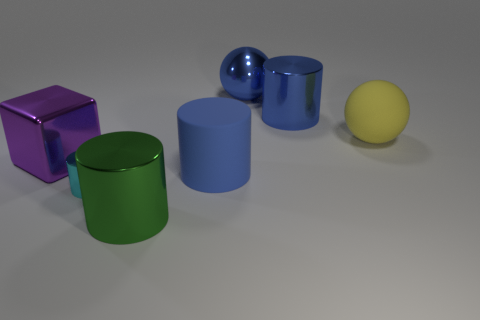Add 2 big purple cubes. How many objects exist? 9 Subtract all balls. How many objects are left? 5 Subtract 1 cyan cylinders. How many objects are left? 6 Subtract all big green metallic cylinders. Subtract all large blue matte cylinders. How many objects are left? 5 Add 7 large yellow matte balls. How many large yellow matte balls are left? 8 Add 4 blue matte cylinders. How many blue matte cylinders exist? 5 